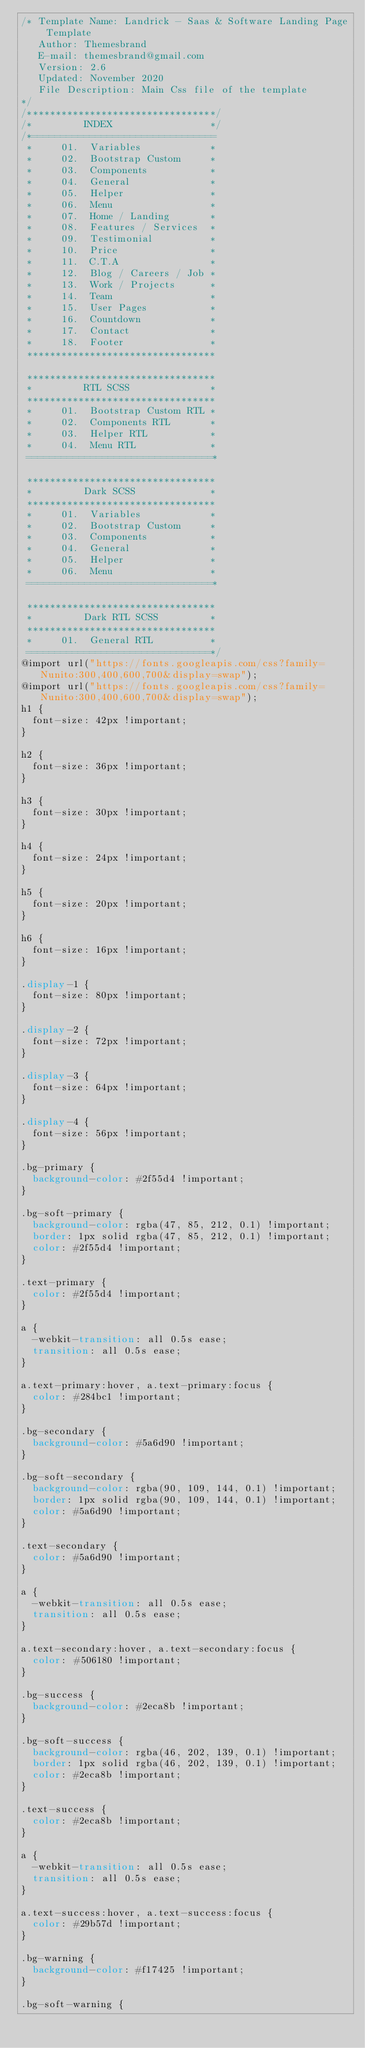Convert code to text. <code><loc_0><loc_0><loc_500><loc_500><_CSS_>/* Template Name: Landrick - Saas & Software Landing Page Template
   Author: Themesbrand
   E-mail: themesbrand@gmail.com
   Version: 2.6
   Updated: November 2020
   File Description: Main Css file of the template
*/
/*********************************/
/*         INDEX                 */
/*================================
 *     01.  Variables            *
 *     02.  Bootstrap Custom     *
 *     03.  Components           *
 *     04.  General              *
 *     05.  Helper               *
 *     06.  Menu                 *
 *     07.  Home / Landing       *
 *     08.  Features / Services  *
 *     09.  Testimonial          *
 *     10.  Price                *
 *     11.  C.T.A                *
 *     12.  Blog / Careers / Job *
 *     13.  Work / Projects      *
 *     14.  Team                 *
 *     15.  User Pages           *
 *     16.  Countdown            *
 *     17.  Contact              *
 *     18.  Footer               *
 *********************************

 *********************************
 *         RTL SCSS              *
 *********************************
 *     01.  Bootstrap Custom RTL *
 *     02.  Components RTL       *
 *     03.  Helper RTL           *
 *     04.  Menu RTL             *
 ================================*
 
 *********************************
 *         Dark SCSS             *
 *********************************
 *     01.  Variables            *
 *     02.  Bootstrap Custom     *
 *     03.  Components           *
 *     04.  General              *
 *     05.  Helper               *
 *     06.  Menu                 *
 ================================*
 
 *********************************
 *         Dark RTL SCSS         *
 *********************************
 *     01.  General RTL          *
 ================================*/
@import url("https://fonts.googleapis.com/css?family=Nunito:300,400,600,700&display=swap");
@import url("https://fonts.googleapis.com/css?family=Nunito:300,400,600,700&display=swap");
h1 {
  font-size: 42px !important;
}

h2 {
  font-size: 36px !important;
}

h3 {
  font-size: 30px !important;
}

h4 {
  font-size: 24px !important;
}

h5 {
  font-size: 20px !important;
}

h6 {
  font-size: 16px !important;
}

.display-1 {
  font-size: 80px !important;
}

.display-2 {
  font-size: 72px !important;
}

.display-3 {
  font-size: 64px !important;
}

.display-4 {
  font-size: 56px !important;
}

.bg-primary {
  background-color: #2f55d4 !important;
}

.bg-soft-primary {
  background-color: rgba(47, 85, 212, 0.1) !important;
  border: 1px solid rgba(47, 85, 212, 0.1) !important;
  color: #2f55d4 !important;
}

.text-primary {
  color: #2f55d4 !important;
}

a {
  -webkit-transition: all 0.5s ease;
  transition: all 0.5s ease;
}

a.text-primary:hover, a.text-primary:focus {
  color: #284bc1 !important;
}

.bg-secondary {
  background-color: #5a6d90 !important;
}

.bg-soft-secondary {
  background-color: rgba(90, 109, 144, 0.1) !important;
  border: 1px solid rgba(90, 109, 144, 0.1) !important;
  color: #5a6d90 !important;
}

.text-secondary {
  color: #5a6d90 !important;
}

a {
  -webkit-transition: all 0.5s ease;
  transition: all 0.5s ease;
}

a.text-secondary:hover, a.text-secondary:focus {
  color: #506180 !important;
}

.bg-success {
  background-color: #2eca8b !important;
}

.bg-soft-success {
  background-color: rgba(46, 202, 139, 0.1) !important;
  border: 1px solid rgba(46, 202, 139, 0.1) !important;
  color: #2eca8b !important;
}

.text-success {
  color: #2eca8b !important;
}

a {
  -webkit-transition: all 0.5s ease;
  transition: all 0.5s ease;
}

a.text-success:hover, a.text-success:focus {
  color: #29b57d !important;
}

.bg-warning {
  background-color: #f17425 !important;
}

.bg-soft-warning {</code> 